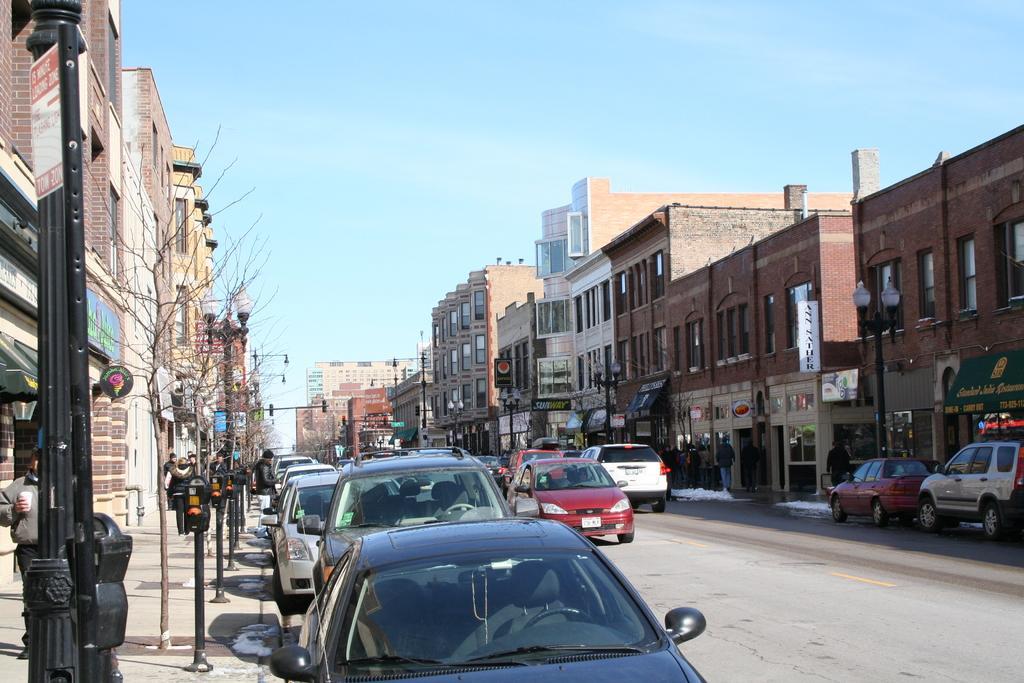Could you give a brief overview of what you see in this image? In this image on the right side and left side there are some buildings, poles, boards. And on the boards there is text and also there are some vehicles, trees and some persons are walking on pavement. At the bottom there is road and at the top there is sky. 